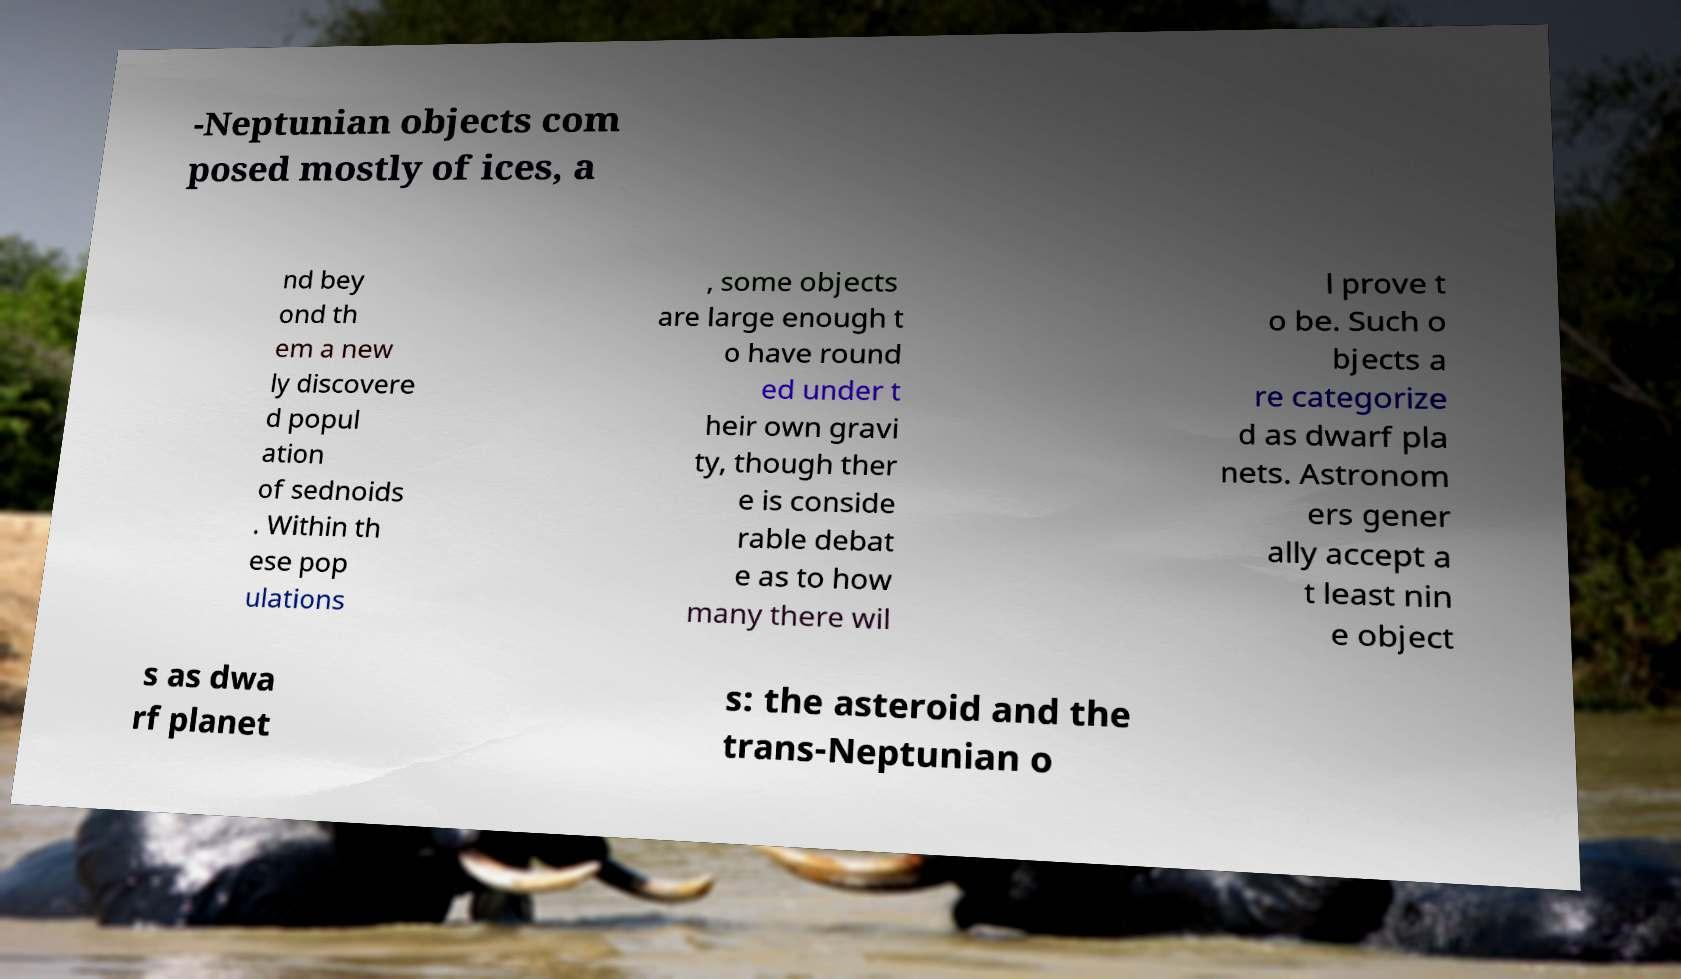Please read and relay the text visible in this image. What does it say? -Neptunian objects com posed mostly of ices, a nd bey ond th em a new ly discovere d popul ation of sednoids . Within th ese pop ulations , some objects are large enough t o have round ed under t heir own gravi ty, though ther e is conside rable debat e as to how many there wil l prove t o be. Such o bjects a re categorize d as dwarf pla nets. Astronom ers gener ally accept a t least nin e object s as dwa rf planet s: the asteroid and the trans-Neptunian o 